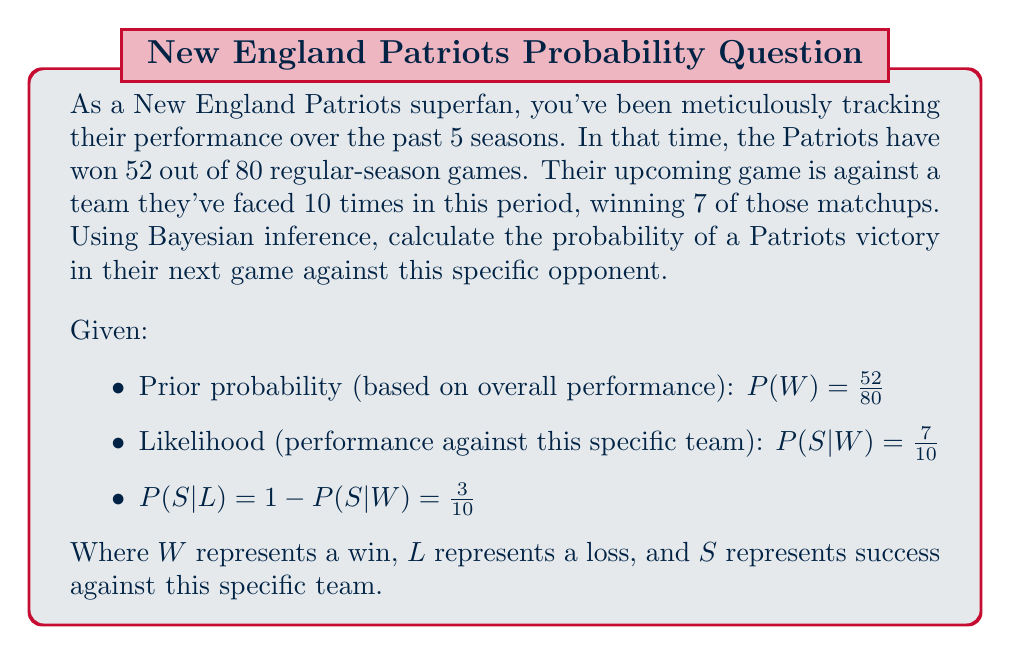Help me with this question. To solve this problem using Bayesian inference, we'll follow these steps:

1) First, let's recall Bayes' theorem:

   $$P(W|S) = \frac{P(S|W) \cdot P(W)}{P(S)}$$

2) We're given the prior probability $P(W) = \frac{52}{80} = 0.65$

3) We're also given the likelihood $P(S|W) = \frac{7}{10} = 0.7$

4) To find $P(S)$, we use the law of total probability:

   $$P(S) = P(S|W) \cdot P(W) + P(S|L) \cdot P(L)$$

5) We know $P(L) = 1 - P(W) = 1 - 0.65 = 0.35$

6) Substituting the values:

   $$P(S) = 0.7 \cdot 0.65 + 0.3 \cdot 0.35 = 0.455 + 0.105 = 0.56$$

7) Now we can apply Bayes' theorem:

   $$P(W|S) = \frac{0.7 \cdot 0.65}{0.56} = \frac{0.455}{0.56} \approx 0.8125$$

Therefore, based on the historical data and using Bayesian inference, the probability of a Patriots victory in their next game against this specific opponent is approximately 0.8125 or 81.25%.
Answer: $0.8125$ or $81.25\%$ 